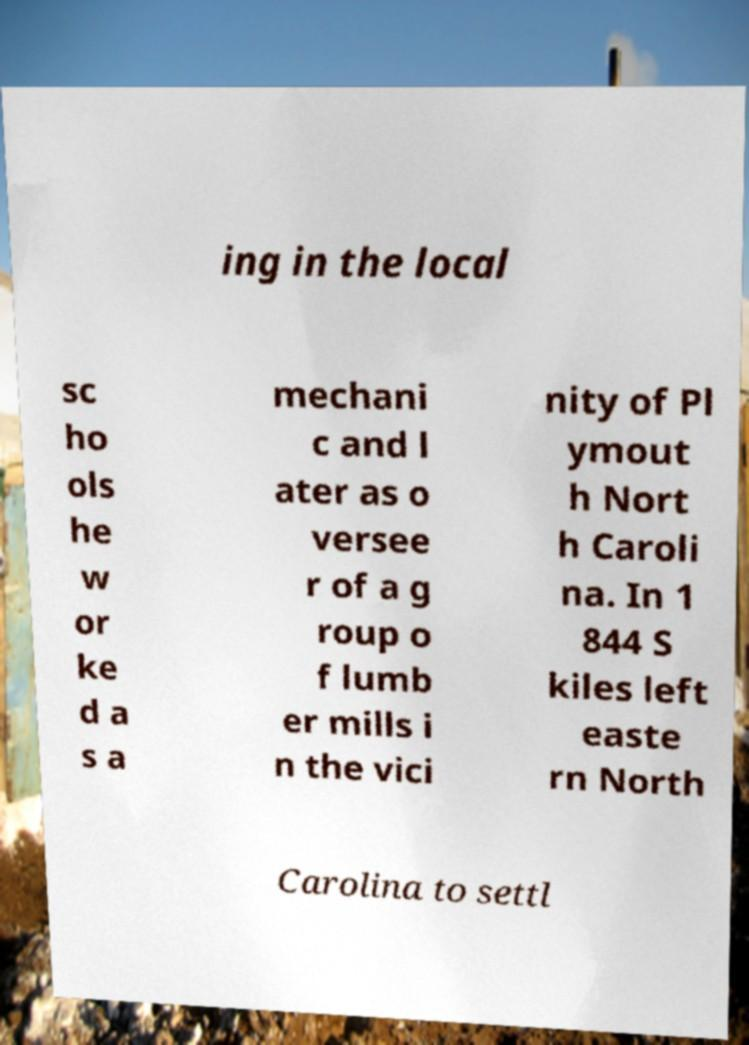There's text embedded in this image that I need extracted. Can you transcribe it verbatim? ing in the local sc ho ols he w or ke d a s a mechani c and l ater as o versee r of a g roup o f lumb er mills i n the vici nity of Pl ymout h Nort h Caroli na. In 1 844 S kiles left easte rn North Carolina to settl 